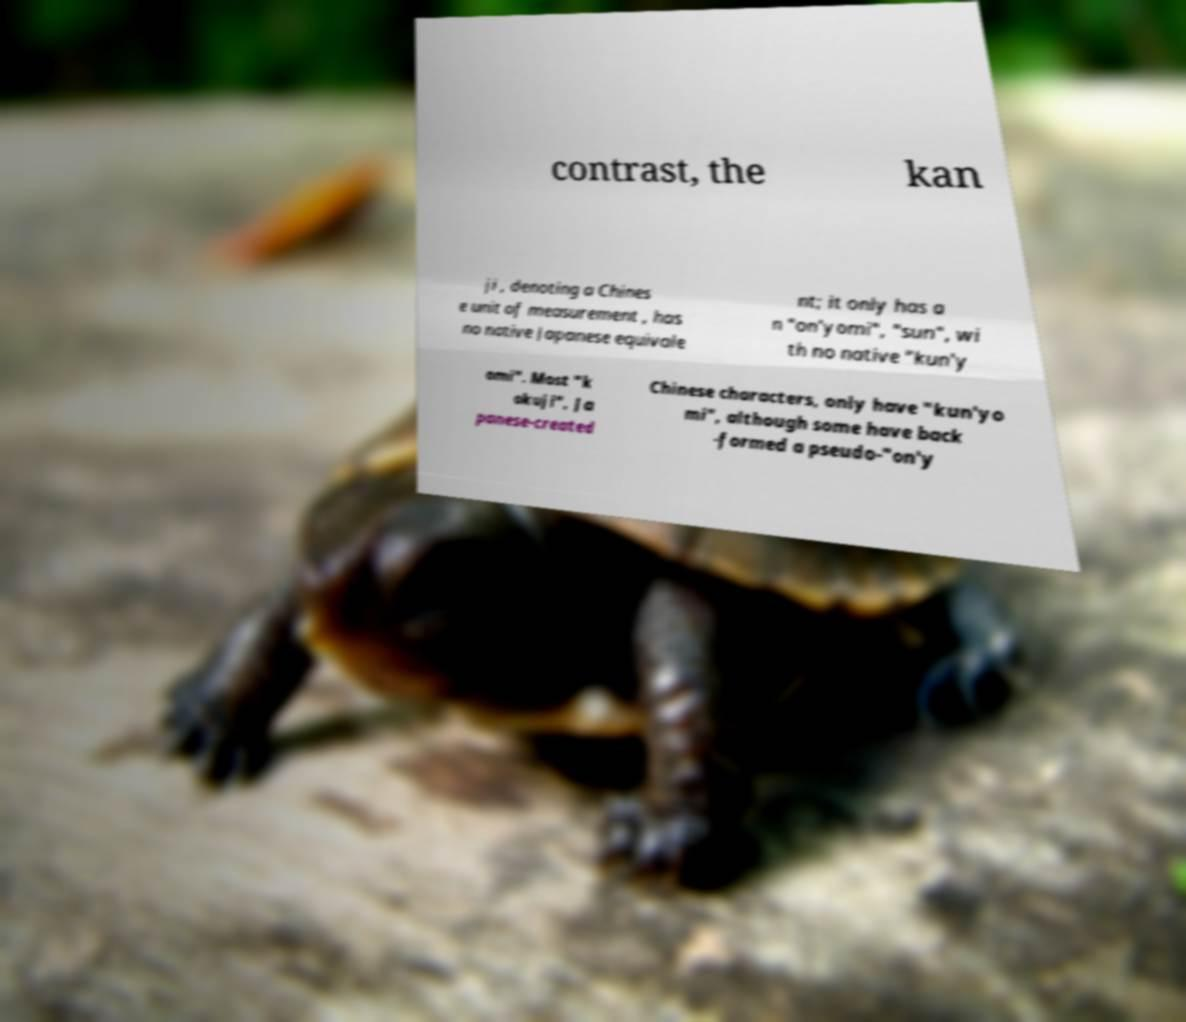Can you accurately transcribe the text from the provided image for me? contrast, the kan ji , denoting a Chines e unit of measurement , has no native Japanese equivale nt; it only has a n "on'yomi", "sun", wi th no native "kun'y omi". Most "k okuji", Ja panese-created Chinese characters, only have "kun'yo mi", although some have back -formed a pseudo-"on'y 